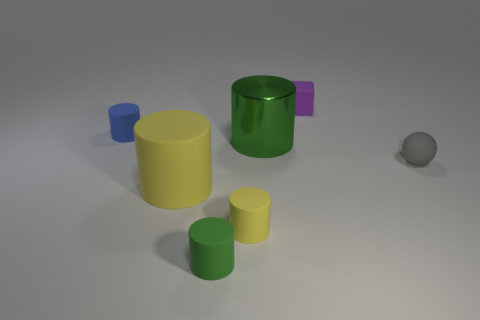Add 1 green things. How many objects exist? 8 Subtract all rubber cylinders. How many cylinders are left? 1 Subtract all large purple matte cubes. Subtract all matte cubes. How many objects are left? 6 Add 5 gray rubber balls. How many gray rubber balls are left? 6 Add 3 brown metal objects. How many brown metal objects exist? 3 Subtract all blue cylinders. How many cylinders are left? 4 Subtract 0 yellow spheres. How many objects are left? 7 Subtract all cylinders. How many objects are left? 2 Subtract 3 cylinders. How many cylinders are left? 2 Subtract all blue cylinders. Subtract all brown balls. How many cylinders are left? 4 